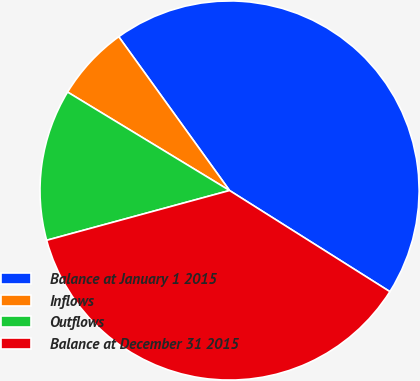Convert chart. <chart><loc_0><loc_0><loc_500><loc_500><pie_chart><fcel>Balance at January 1 2015<fcel>Inflows<fcel>Outflows<fcel>Balance at December 31 2015<nl><fcel>43.89%<fcel>6.37%<fcel>12.92%<fcel>36.81%<nl></chart> 